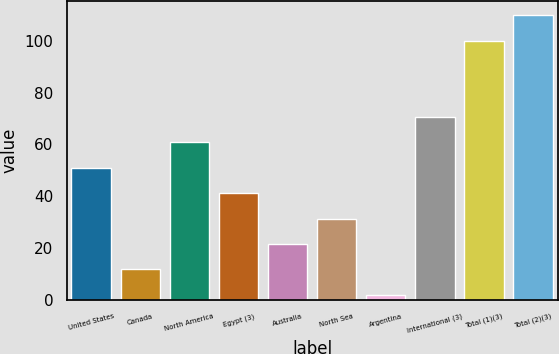<chart> <loc_0><loc_0><loc_500><loc_500><bar_chart><fcel>United States<fcel>Canada<fcel>North America<fcel>Egypt (3)<fcel>Australia<fcel>North Sea<fcel>Argentina<fcel>International (3)<fcel>Total (1)(3)<fcel>Total (2)(3)<nl><fcel>51<fcel>11.8<fcel>60.8<fcel>41.2<fcel>21.6<fcel>31.4<fcel>2<fcel>70.6<fcel>100<fcel>109.8<nl></chart> 